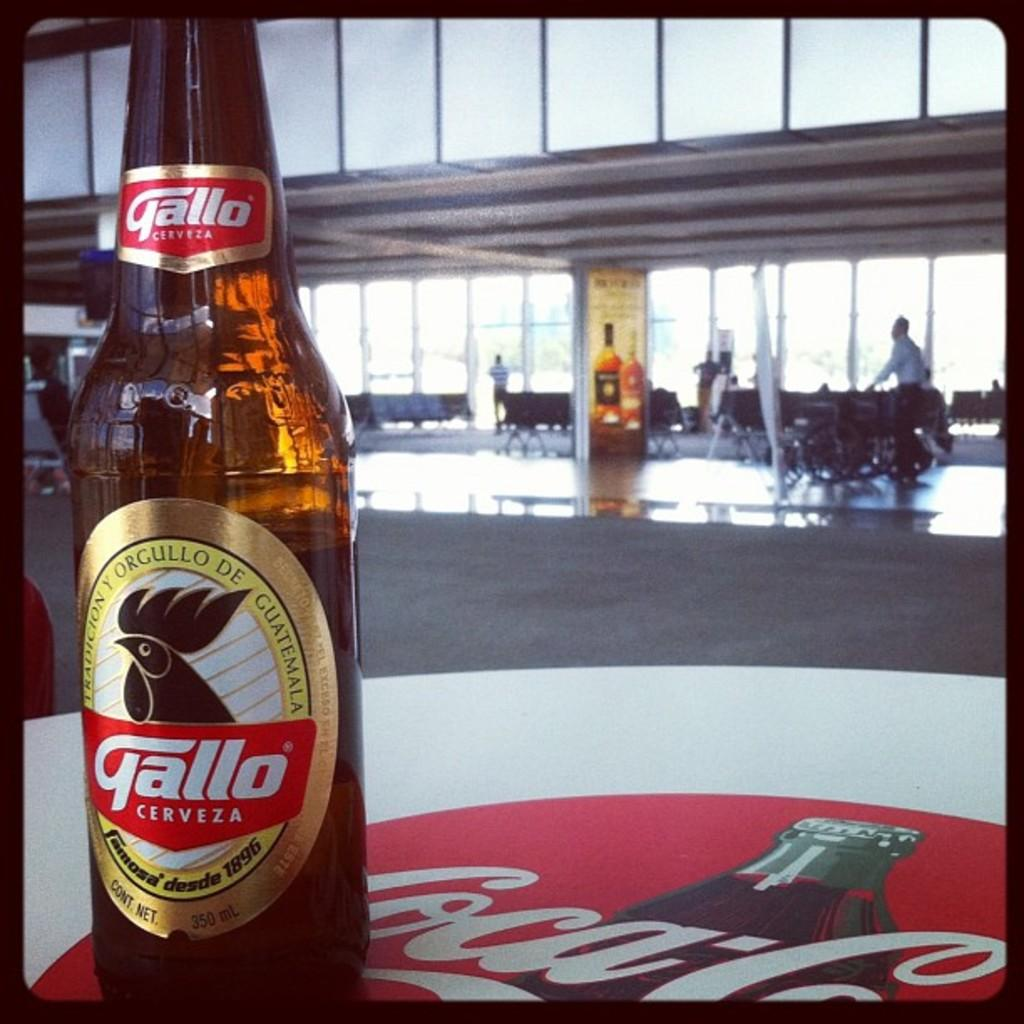<image>
Relay a brief, clear account of the picture shown. A bottle of Gallo Cerveza sitting on a table with a Coca Cola label on the table. 